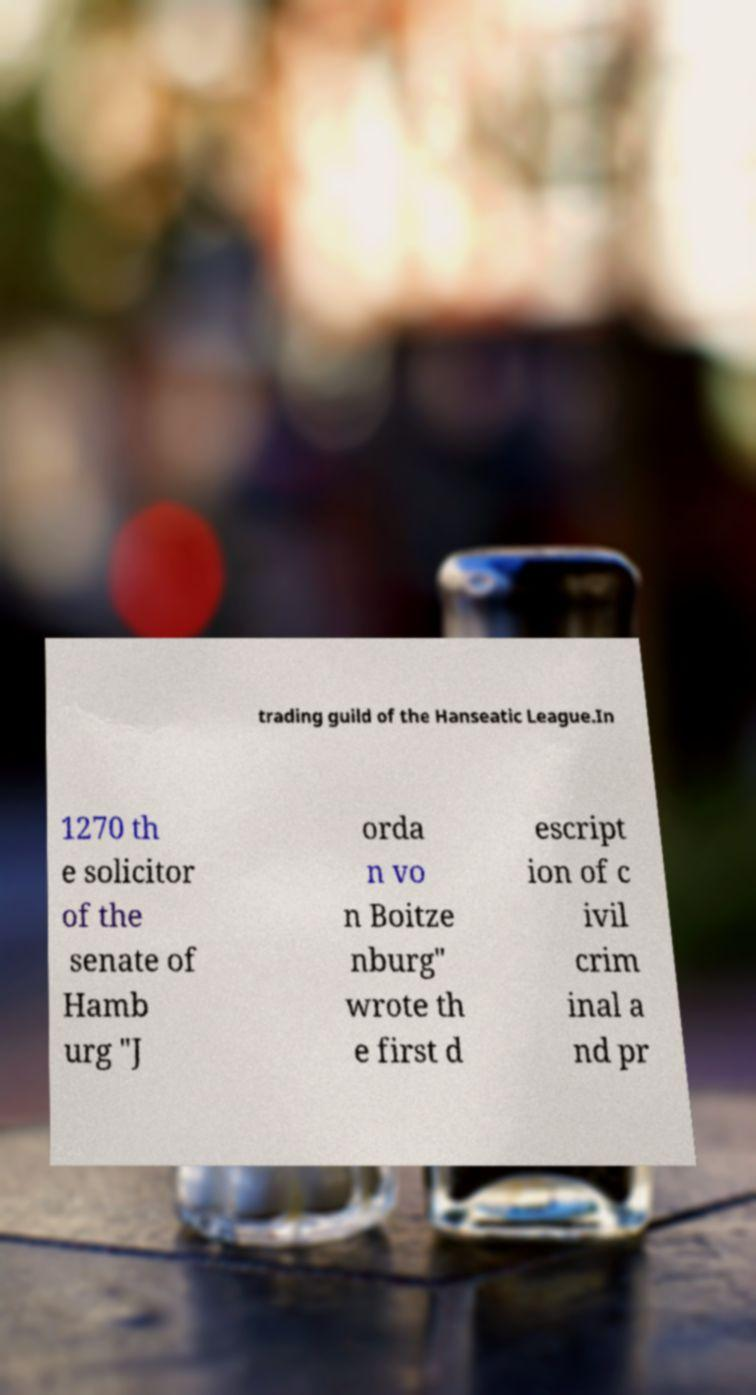Please identify and transcribe the text found in this image. trading guild of the Hanseatic League.In 1270 th e solicitor of the senate of Hamb urg "J orda n vo n Boitze nburg" wrote th e first d escript ion of c ivil crim inal a nd pr 